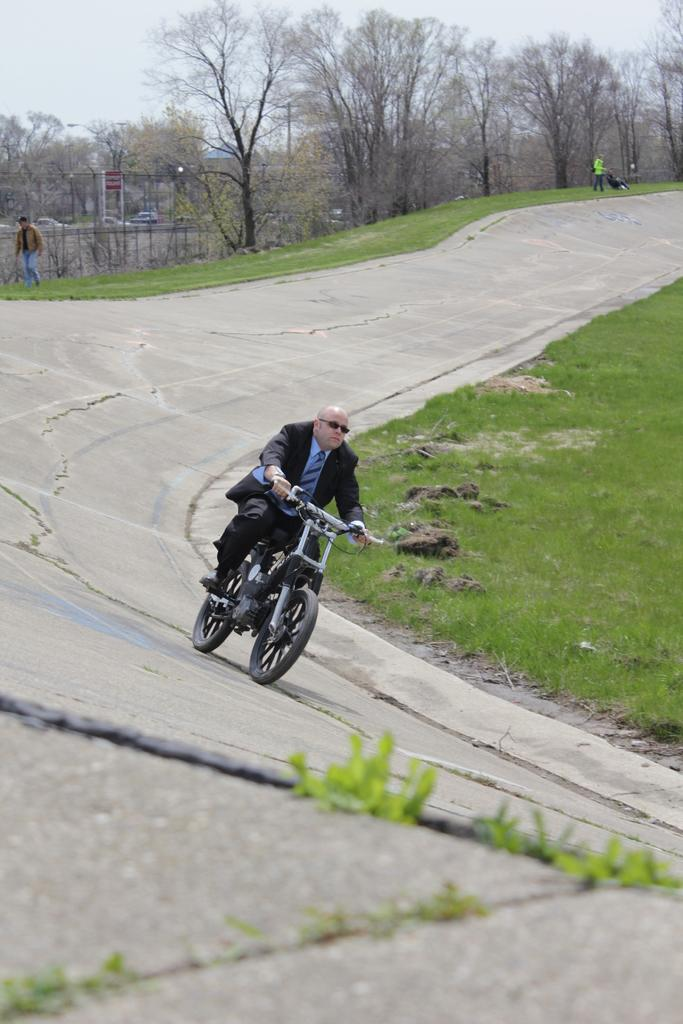What is the main subject of the image? There is a person in the image. What is the person wearing? The person is wearing a black suit. What activity is the person engaged in? The person is riding a bike. Where is the bike located? The bike is on the road. What can be seen in the background of the image? There are trees in the background of the image. What type of vegetation is present on the ground on either side of the road? The ground on either side of the road has greenery. What type of plastic is used to make the pig's range in the image? There is no pig or plastic in the image, and therefore no such range can be observed. 